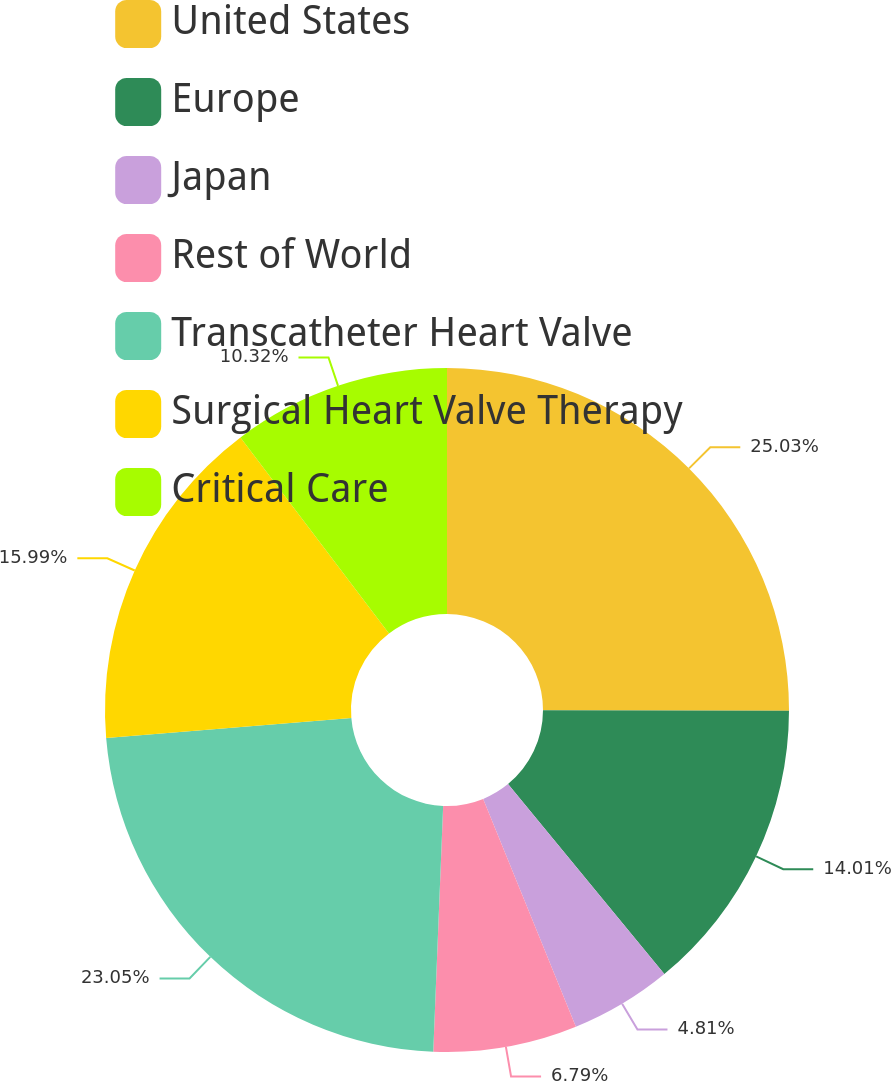Convert chart. <chart><loc_0><loc_0><loc_500><loc_500><pie_chart><fcel>United States<fcel>Europe<fcel>Japan<fcel>Rest of World<fcel>Transcatheter Heart Valve<fcel>Surgical Heart Valve Therapy<fcel>Critical Care<nl><fcel>25.03%<fcel>14.01%<fcel>4.81%<fcel>6.79%<fcel>23.05%<fcel>15.99%<fcel>10.32%<nl></chart> 